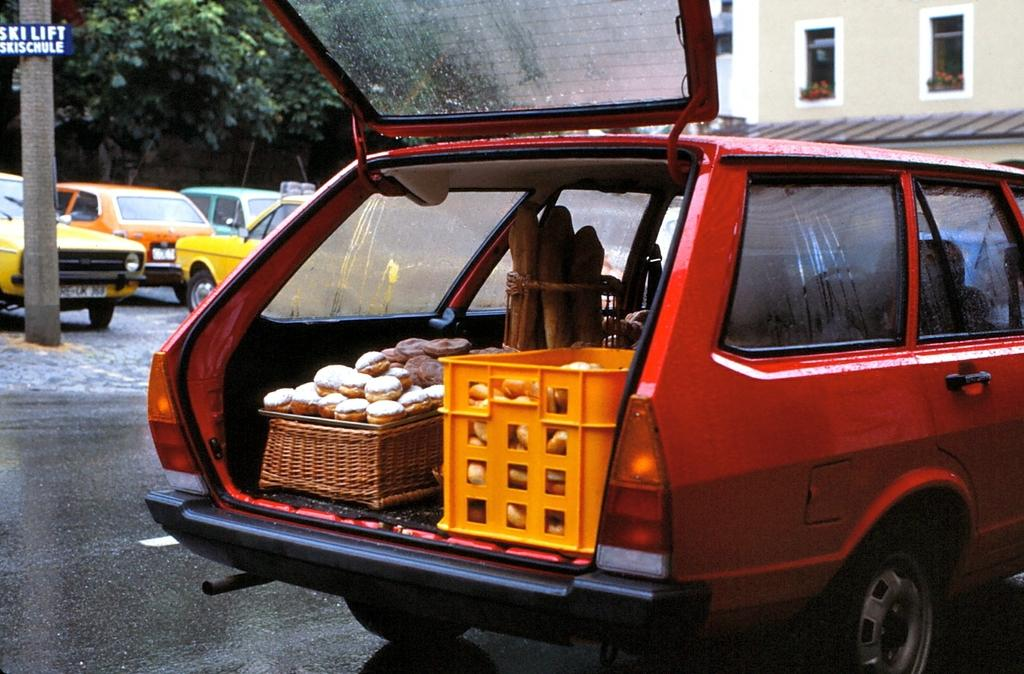Provide a one-sentence caption for the provided image. A car with its hatch open and in the background is a sign reading ski lift. 